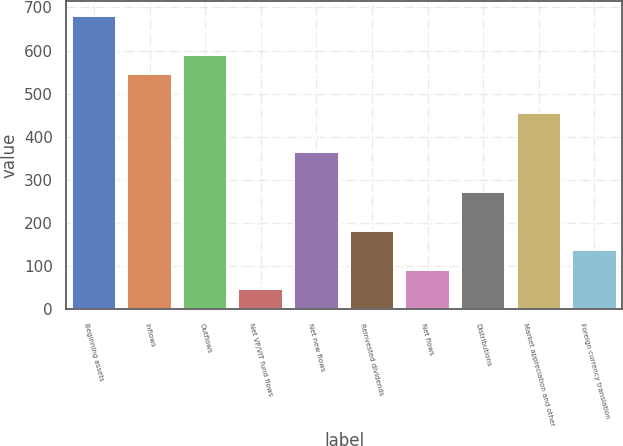Convert chart to OTSL. <chart><loc_0><loc_0><loc_500><loc_500><bar_chart><fcel>Beginning assets<fcel>Inflows<fcel>Outflows<fcel>Net VP/VIT fund flows<fcel>Net new flows<fcel>Reinvested dividends<fcel>Net flows<fcel>Distributions<fcel>Market appreciation and other<fcel>Foreign currency translation<nl><fcel>680.95<fcel>545.02<fcel>590.33<fcel>46.61<fcel>363.78<fcel>182.54<fcel>91.92<fcel>273.16<fcel>454.4<fcel>137.23<nl></chart> 